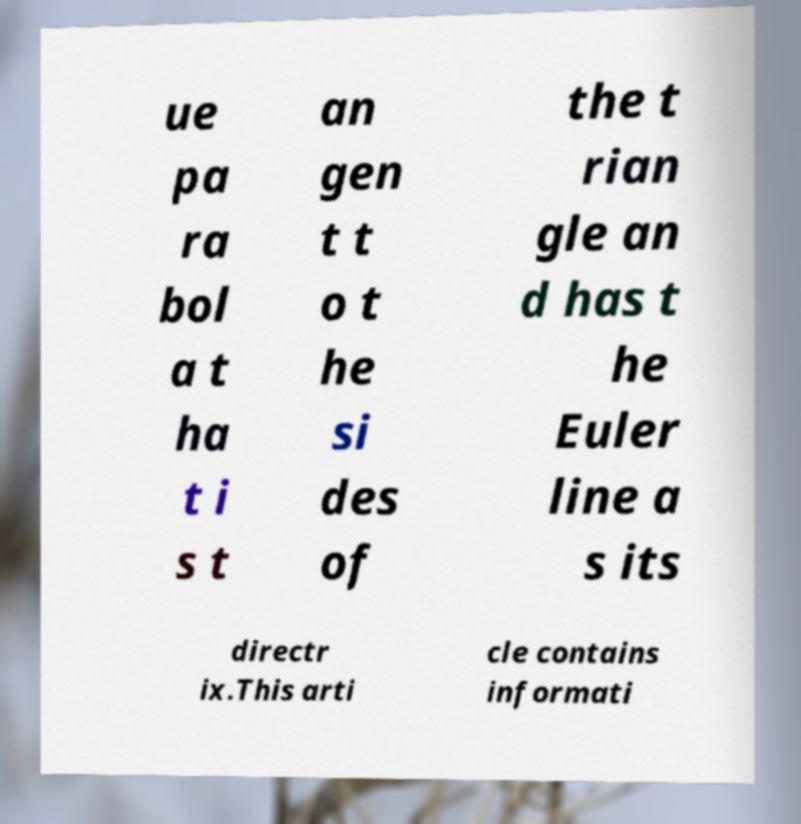Could you assist in decoding the text presented in this image and type it out clearly? ue pa ra bol a t ha t i s t an gen t t o t he si des of the t rian gle an d has t he Euler line a s its directr ix.This arti cle contains informati 